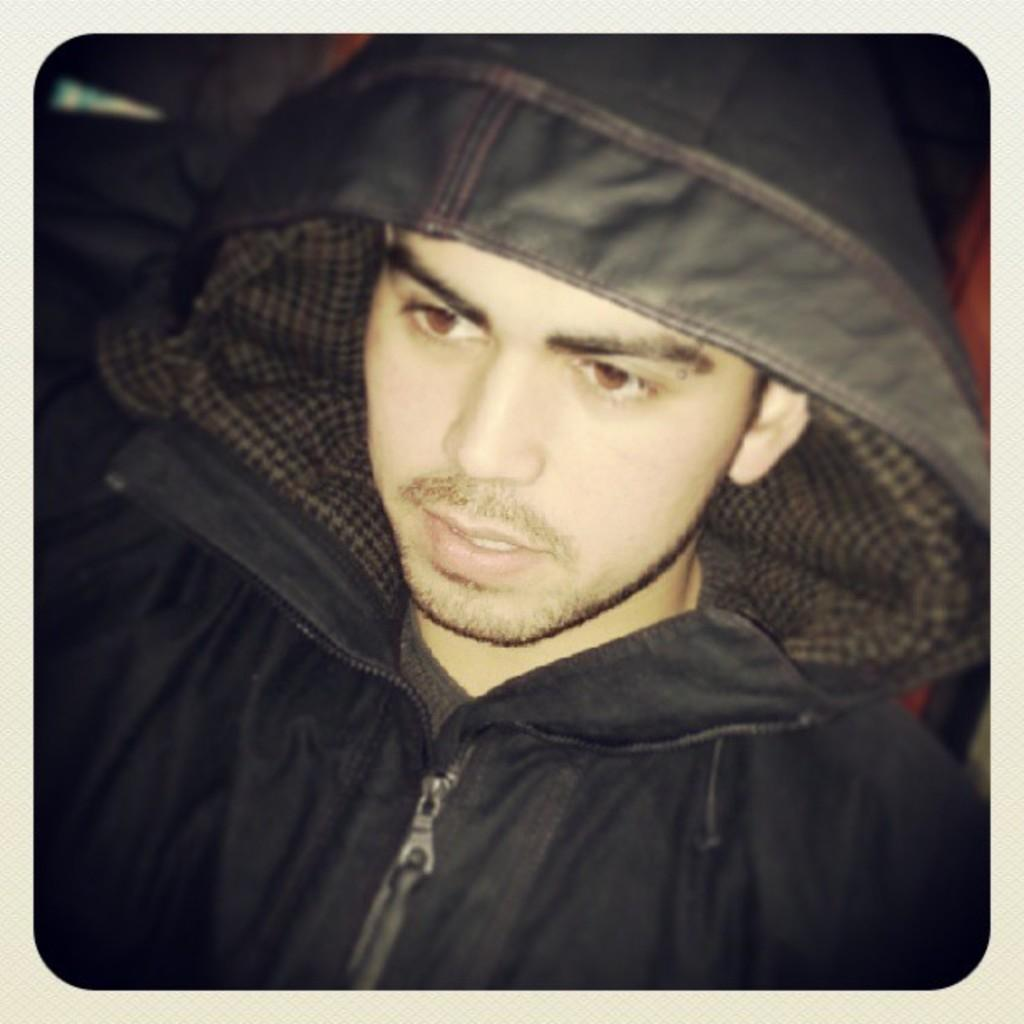What is the main subject of the image? There is a man in the image. What is the man wearing? The man is wearing a jacket. Where is the man positioned in the image? The man is located in the center of the image. What type of arithmetic problem is the man solving in the image? There is no arithmetic problem present in the image; it only features a man wearing a jacket and standing in the center. 